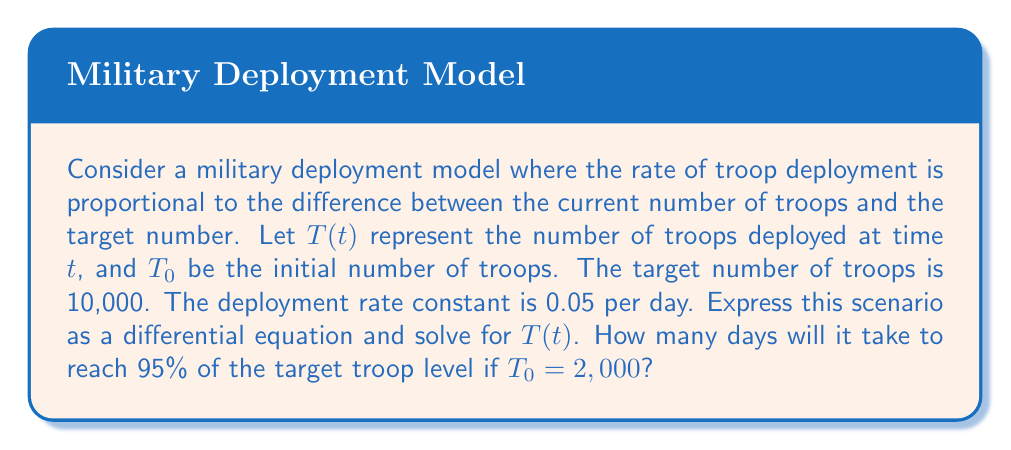Show me your answer to this math problem. 1) First, let's express the scenario as a differential equation:
   $$\frac{dT}{dt} = 0.05(10000 - T)$$

2) This is a first-order linear differential equation. The general solution is:
   $$T(t) = 10000 - (10000 - T_0)e^{-0.05t}$$

3) Substitute $T_0 = 2000$:
   $$T(t) = 10000 - 8000e^{-0.05t}$$

4) To find when we reach 95% of the target, set $T(t) = 0.95 \times 10000 = 9500$:
   $$9500 = 10000 - 8000e^{-0.05t}$$

5) Solve for $t$:
   $$8000e^{-0.05t} = 500$$
   $$e^{-0.05t} = \frac{1}{16}$$
   $$-0.05t = \ln(\frac{1}{16}) = -\ln(16)$$
   $$t = \frac{\ln(16)}{0.05} \approx 55.45$$

6) Therefore, it will take approximately 55.45 days to reach 95% of the target troop level.
Answer: 55.45 days 